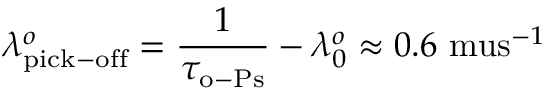Convert formula to latex. <formula><loc_0><loc_0><loc_500><loc_500>\lambda _ { p i c k - o f f } ^ { o } = \frac { 1 } { \tau _ { o - P s } } - \lambda _ { 0 } ^ { o } \approx 0 . 6 \ m u s ^ { - 1 }</formula> 